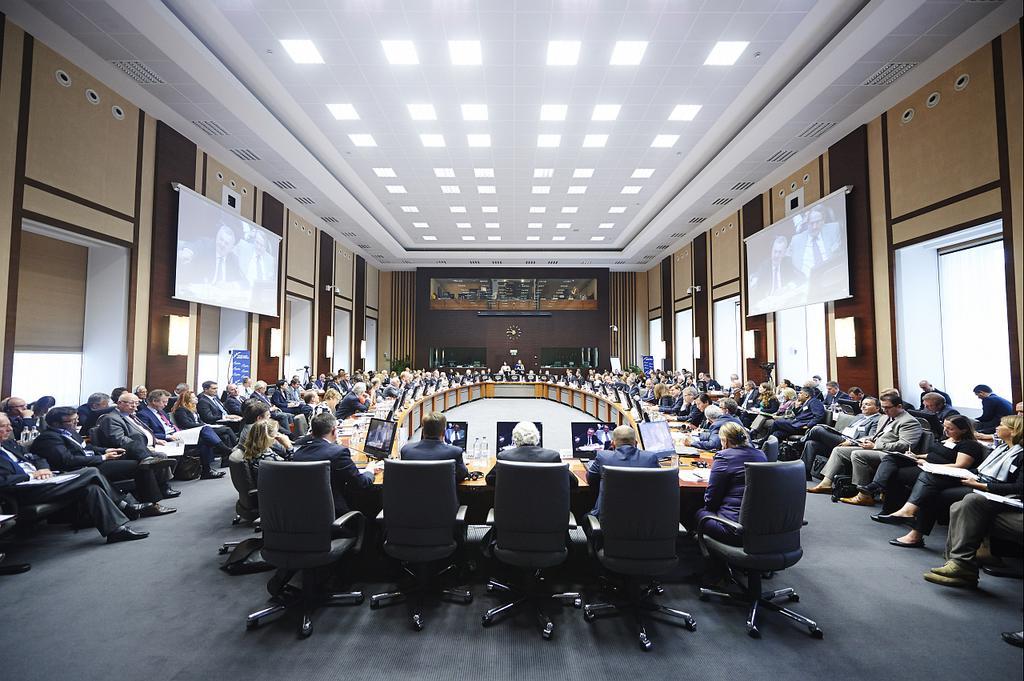Please provide a concise description of this image. In this image few persons are sitting on the chairs and few persons are sitting before a table having few monitors , bottles and few objects on it. There are few screen attached to the wall having few windows. Few lights are attached to the roof. 